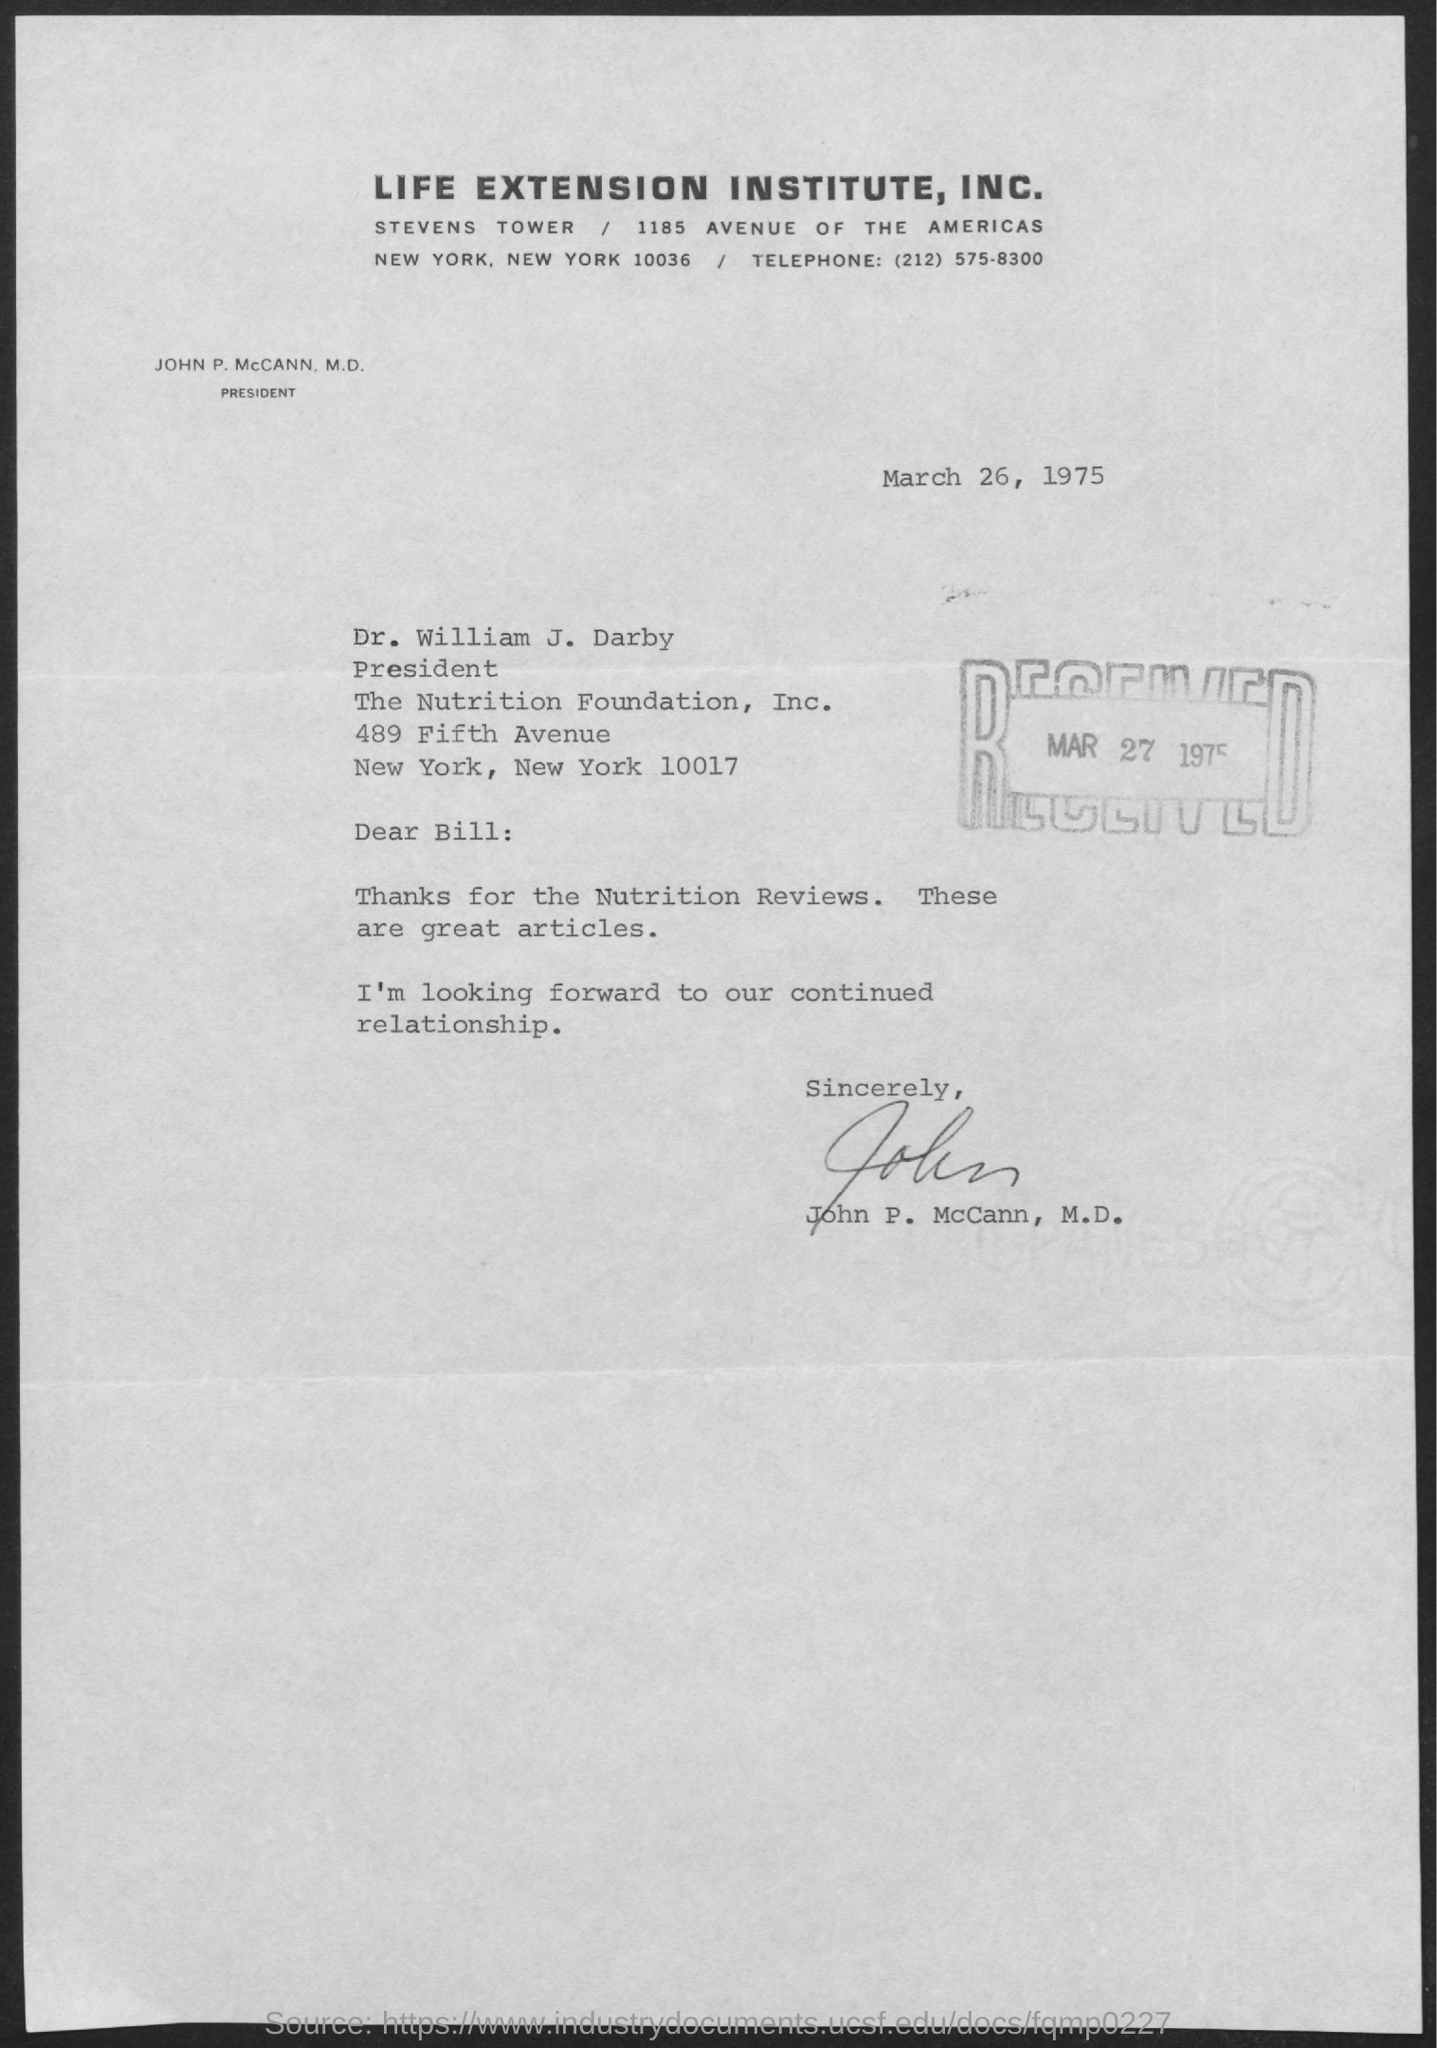Mention a couple of crucial points in this snapshot. The date of the document is March 26, 1975. The letter is addressed to Bill. On March 27, 1975, the letter was received. 